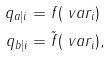<formula> <loc_0><loc_0><loc_500><loc_500>q _ { a | i } & = f ( \ v a r _ { i } ) \\ q _ { b | i } & = \tilde { f } ( \ v a r _ { i } ) ,</formula> 